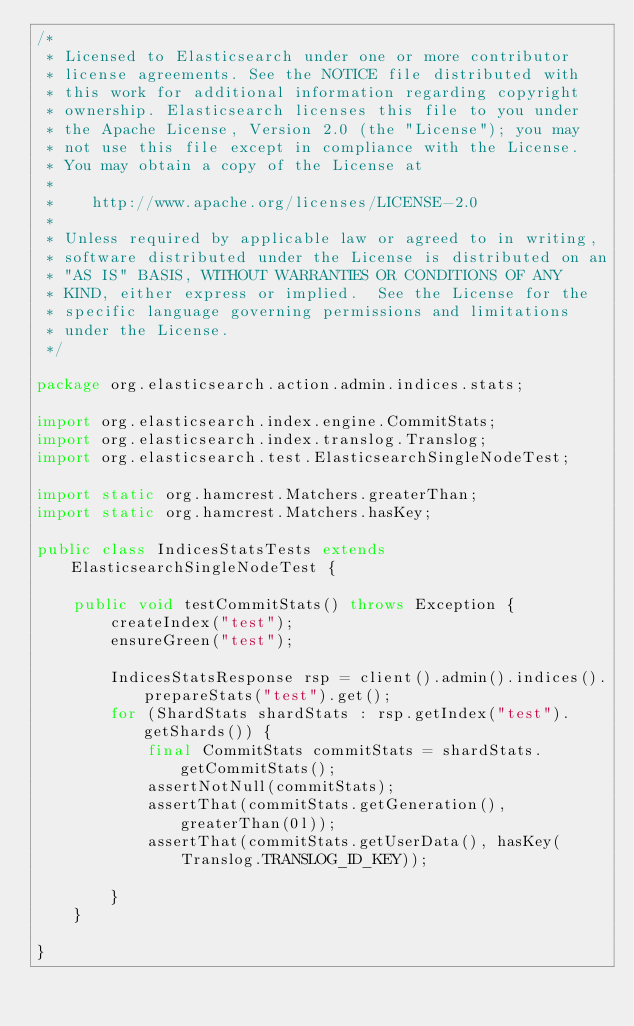<code> <loc_0><loc_0><loc_500><loc_500><_Java_>/*
 * Licensed to Elasticsearch under one or more contributor
 * license agreements. See the NOTICE file distributed with
 * this work for additional information regarding copyright
 * ownership. Elasticsearch licenses this file to you under
 * the Apache License, Version 2.0 (the "License"); you may
 * not use this file except in compliance with the License.
 * You may obtain a copy of the License at
 *
 *    http://www.apache.org/licenses/LICENSE-2.0
 *
 * Unless required by applicable law or agreed to in writing,
 * software distributed under the License is distributed on an
 * "AS IS" BASIS, WITHOUT WARRANTIES OR CONDITIONS OF ANY
 * KIND, either express or implied.  See the License for the
 * specific language governing permissions and limitations
 * under the License.
 */

package org.elasticsearch.action.admin.indices.stats;

import org.elasticsearch.index.engine.CommitStats;
import org.elasticsearch.index.translog.Translog;
import org.elasticsearch.test.ElasticsearchSingleNodeTest;

import static org.hamcrest.Matchers.greaterThan;
import static org.hamcrest.Matchers.hasKey;

public class IndicesStatsTests extends ElasticsearchSingleNodeTest {

    public void testCommitStats() throws Exception {
        createIndex("test");
        ensureGreen("test");

        IndicesStatsResponse rsp = client().admin().indices().prepareStats("test").get();
        for (ShardStats shardStats : rsp.getIndex("test").getShards()) {
            final CommitStats commitStats = shardStats.getCommitStats();
            assertNotNull(commitStats);
            assertThat(commitStats.getGeneration(), greaterThan(0l));
            assertThat(commitStats.getUserData(), hasKey(Translog.TRANSLOG_ID_KEY));

        }
    }

}
</code> 